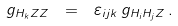<formula> <loc_0><loc_0><loc_500><loc_500>g _ { H _ { k } Z Z } \ = \ \varepsilon _ { i j k } \, g _ { H _ { i } H _ { j } Z } \, .</formula> 